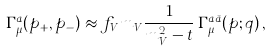<formula> <loc_0><loc_0><loc_500><loc_500>\Gamma ^ { a } _ { \mu } ( p _ { + } , p _ { - } ) \approx f _ { V } m _ { V } \frac { 1 } { m _ { V } ^ { 2 } - t } \, \Gamma _ { \mu } ^ { a \bar { a } } ( p ; q ) \, ,</formula> 